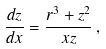Convert formula to latex. <formula><loc_0><loc_0><loc_500><loc_500>\frac { d z } { d x } = \frac { r ^ { 3 } + z ^ { 2 } } { x z } \, ,</formula> 